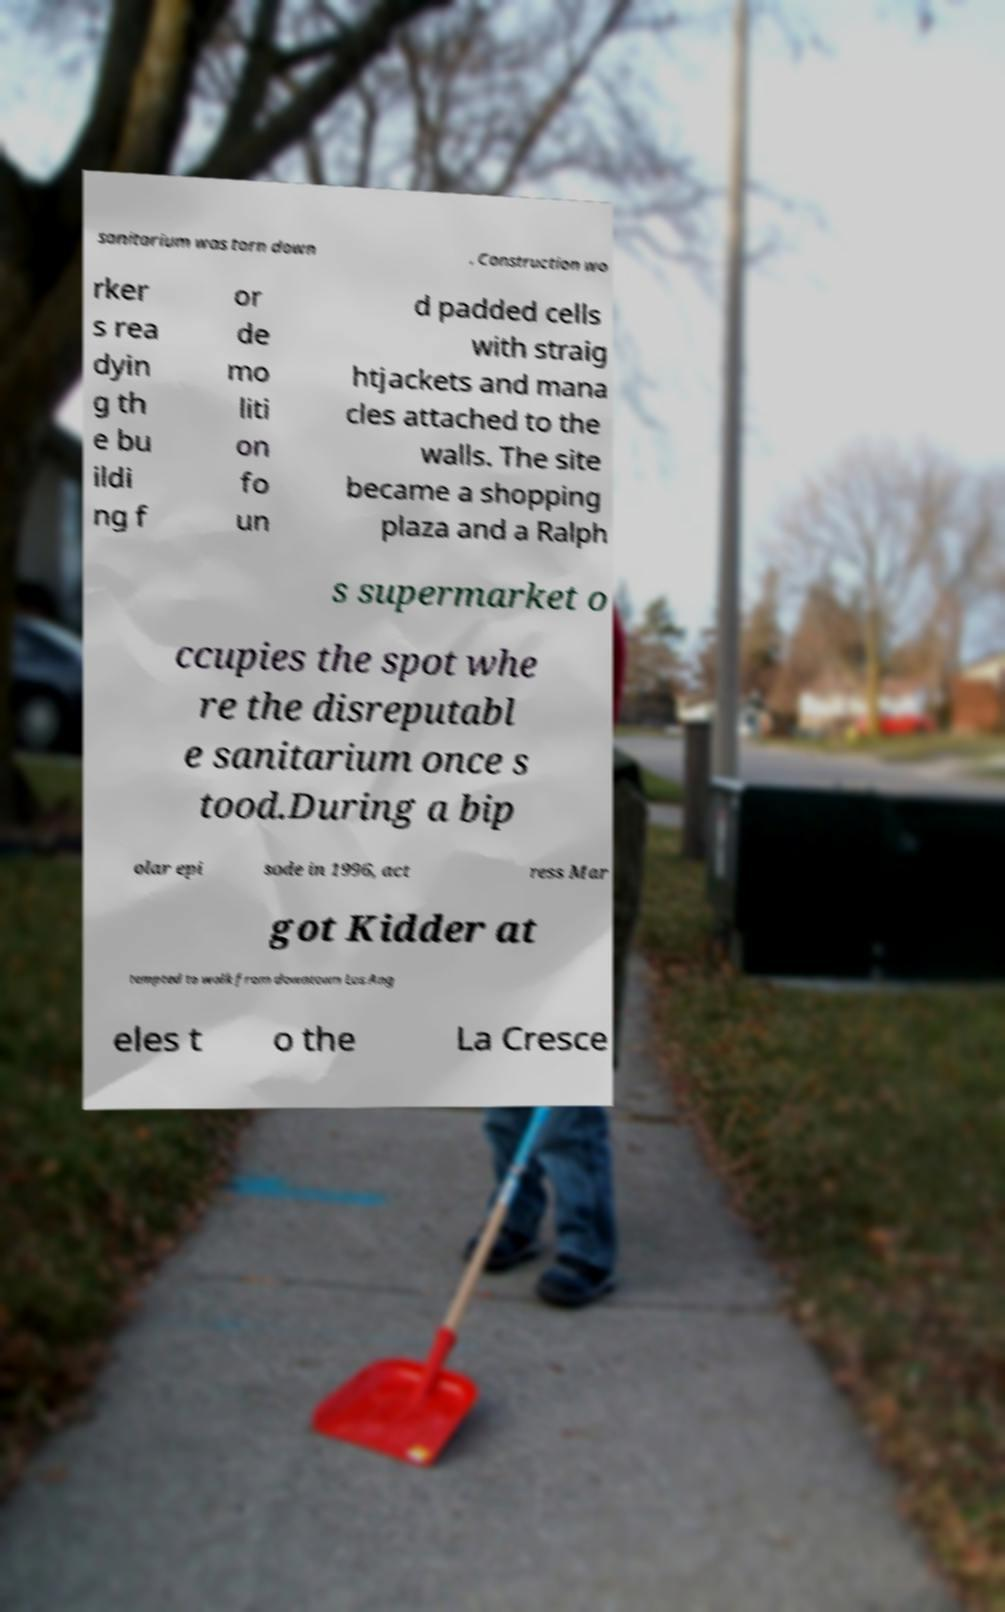Could you assist in decoding the text presented in this image and type it out clearly? sanitarium was torn down . Construction wo rker s rea dyin g th e bu ildi ng f or de mo liti on fo un d padded cells with straig htjackets and mana cles attached to the walls. The site became a shopping plaza and a Ralph s supermarket o ccupies the spot whe re the disreputabl e sanitarium once s tood.During a bip olar epi sode in 1996, act ress Mar got Kidder at tempted to walk from downtown Los Ang eles t o the La Cresce 